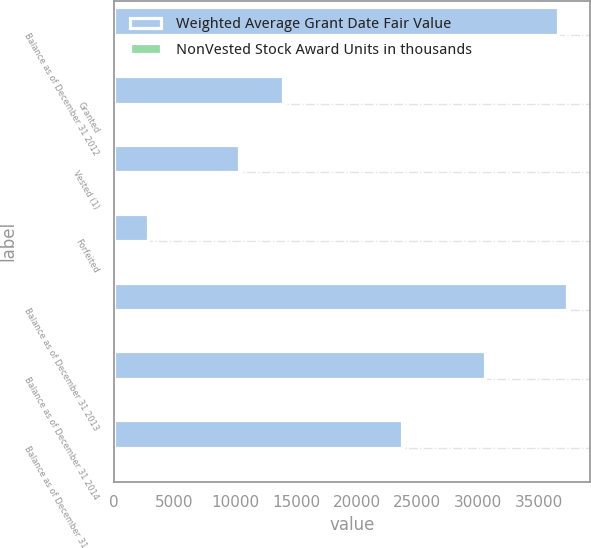Convert chart to OTSL. <chart><loc_0><loc_0><loc_500><loc_500><stacked_bar_chart><ecel><fcel>Balance as of December 31 2012<fcel>Granted<fcel>Vested (1)<fcel>Forfeited<fcel>Balance as of December 31 2013<fcel>Balance as of December 31 2014<fcel>Balance as of December 31 2015<nl><fcel>Weighted Average Grant Date Fair Value<fcel>36593<fcel>13913<fcel>10307<fcel>2860<fcel>37339<fcel>30535<fcel>23764<nl><fcel>NonVested Stock Award Units in thousands<fcel>7<fcel>8<fcel>8<fcel>7<fcel>7<fcel>9<fcel>11<nl></chart> 